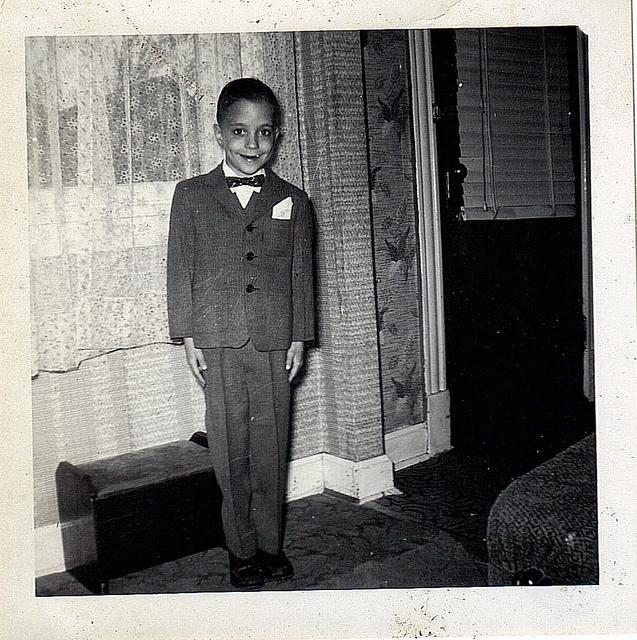Is this picture recent?
Give a very brief answer. No. What is on this boys face?
Keep it brief. Smile. How young is this boy?
Be succinct. 8. 